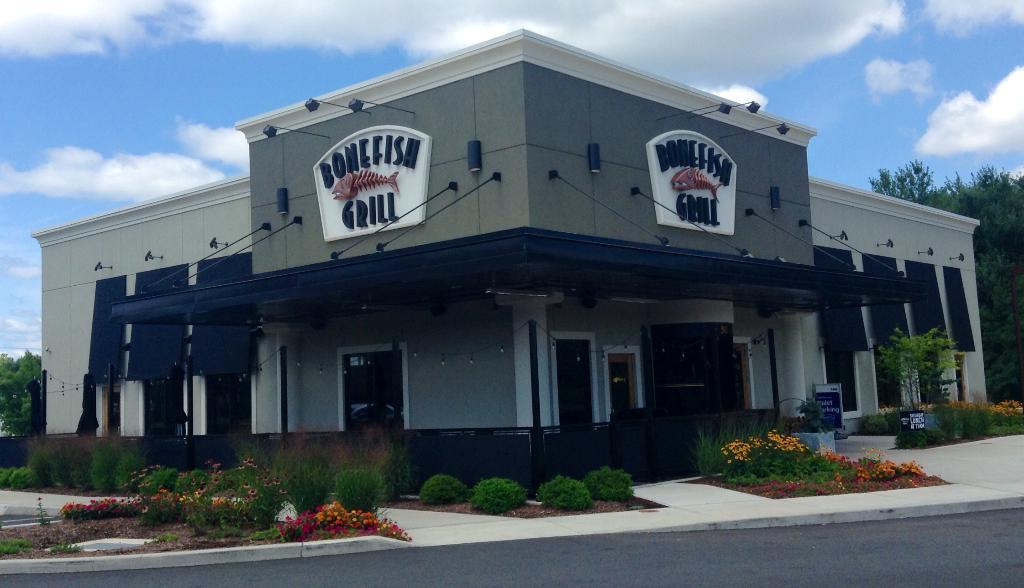In one or two sentences, can you explain what this image depicts? In this picture we can see plants, road, flowers, boards and building. In the background of the image we can see trees and sky with clouds. 